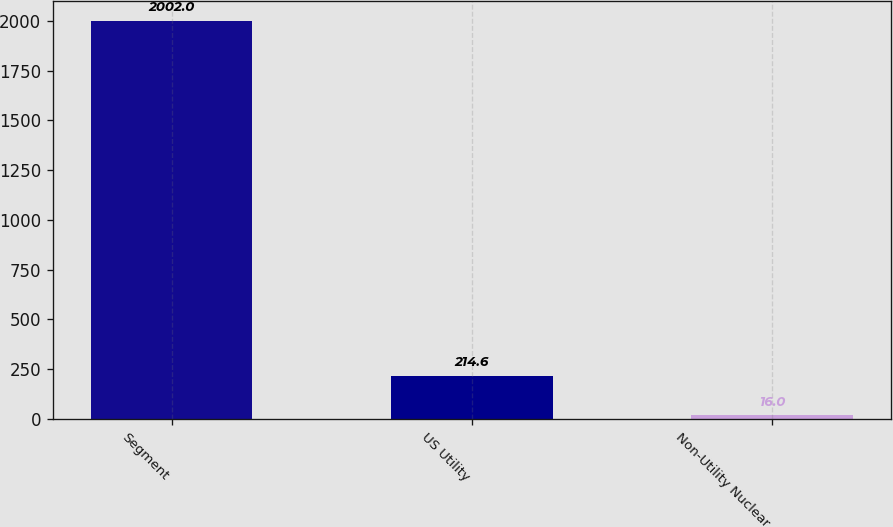Convert chart to OTSL. <chart><loc_0><loc_0><loc_500><loc_500><bar_chart><fcel>Segment<fcel>US Utility<fcel>Non-Utility Nuclear<nl><fcel>2002<fcel>214.6<fcel>16<nl></chart> 